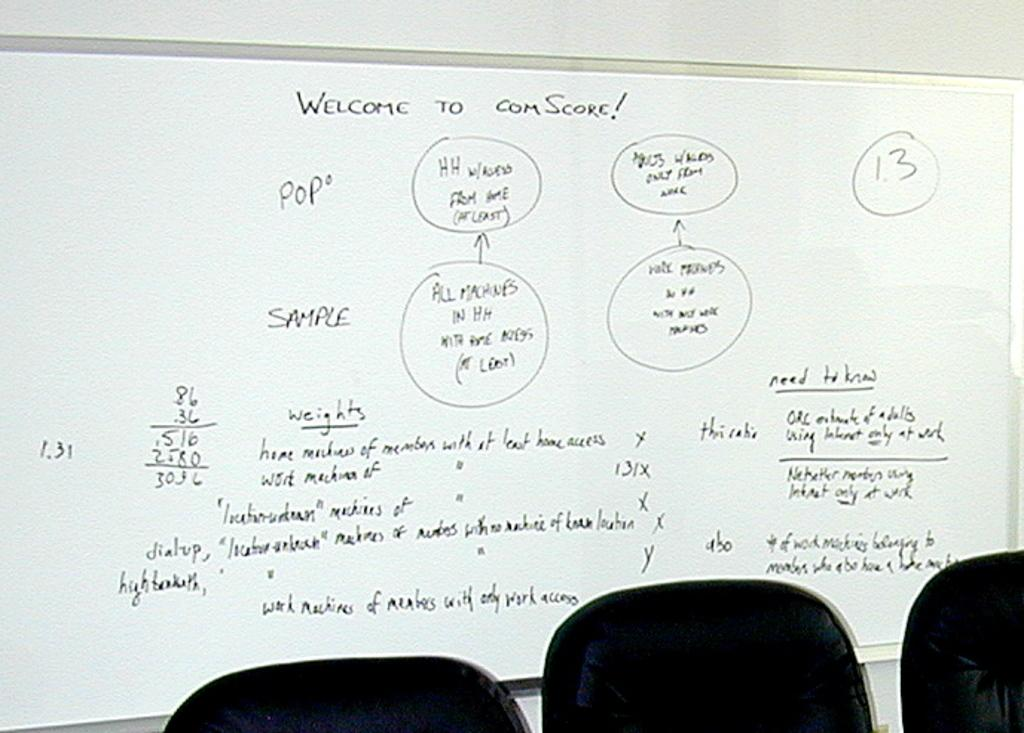What is on the wall in the image? There is a board with texts written on it on the wall. What objects are at the bottom of the image? There are chairs at the bottom of the image. Where is the rake located in the image? There is no rake present in the image. What story is being told by the texts on the board? The image does not provide enough information to determine the story being told by the texts on the board. 